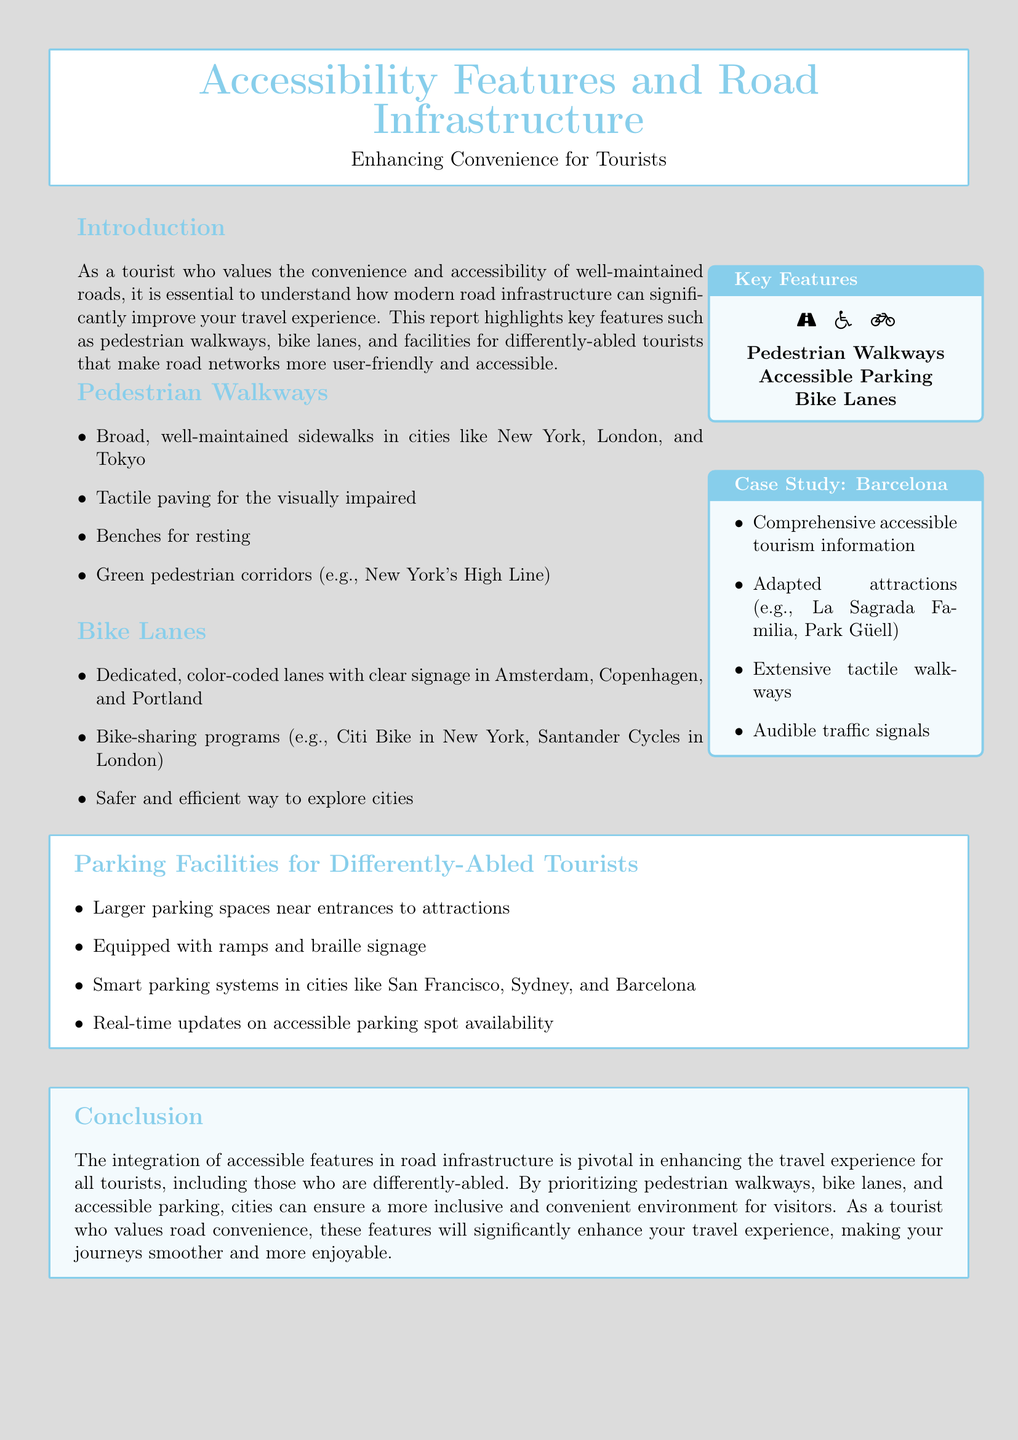What cities are mentioned for pedestrian walkways? The report lists cities like New York, London, and Tokyo for their pedestrian walkways.
Answer: New York, London, Tokyo What feature is used for the visually impaired? The document specifies tactile paving as a feature for assisting the visually impaired.
Answer: Tactile paving Which bike-sharing program is mentioned? The report refers to Citi Bike in New York as a bike-sharing program.
Answer: Citi Bike What type of parking spaces are provided for differently-abled tourists? The document mentions larger parking spaces located near entrances to attractions.
Answer: Larger parking spaces What comprehensive feature is highlighted in Barcelona? The report describes comprehensive accessible tourism information as a key feature in Barcelona.
Answer: Accessible tourism information How many key features are identified in the report? The document lists three key features: pedestrian walkways, accessible parking, and bike lanes.
Answer: Three What technology is utilized for parking updates? The report mentions smart parking systems for real-time updates on accessible parking availability.
Answer: Smart parking systems What type of signal is available for the visually impaired in Barcelona? The report states that audible traffic signals are available for the visually impaired in Barcelona.
Answer: Audible traffic signals Which city's bike lanes are described as dedicated and color-coded? The report describes dedicated, color-coded bike lanes in Amsterdam, Copenhagen, and Portland.
Answer: Amsterdam, Copenhagen, Portland 